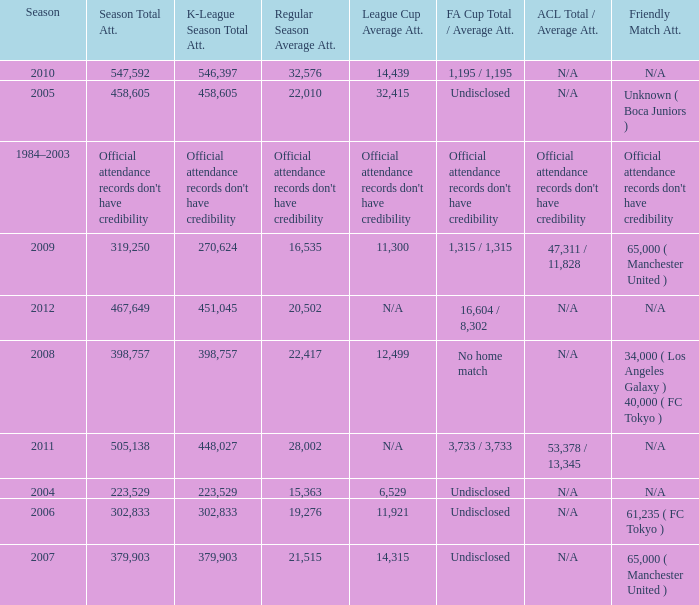Parse the full table. {'header': ['Season', 'Season Total Att.', 'K-League Season Total Att.', 'Regular Season Average Att.', 'League Cup Average Att.', 'FA Cup Total / Average Att.', 'ACL Total / Average Att.', 'Friendly Match Att.'], 'rows': [['2010', '547,592', '546,397', '32,576', '14,439', '1,195 / 1,195', 'N/A', 'N/A'], ['2005', '458,605', '458,605', '22,010', '32,415', 'Undisclosed', 'N/A', 'Unknown ( Boca Juniors )'], ['1984–2003', "Official attendance records don't have credibility", "Official attendance records don't have credibility", "Official attendance records don't have credibility", "Official attendance records don't have credibility", "Official attendance records don't have credibility", "Official attendance records don't have credibility", "Official attendance records don't have credibility"], ['2009', '319,250', '270,624', '16,535', '11,300', '1,315 / 1,315', '47,311 / 11,828', '65,000 ( Manchester United )'], ['2012', '467,649', '451,045', '20,502', 'N/A', '16,604 / 8,302', 'N/A', 'N/A'], ['2008', '398,757', '398,757', '22,417', '12,499', 'No home match', 'N/A', '34,000 ( Los Angeles Galaxy ) 40,000 ( FC Tokyo )'], ['2011', '505,138', '448,027', '28,002', 'N/A', '3,733 / 3,733', '53,378 / 13,345', 'N/A'], ['2004', '223,529', '223,529', '15,363', '6,529', 'Undisclosed', 'N/A', 'N/A'], ['2006', '302,833', '302,833', '19,276', '11,921', 'Undisclosed', 'N/A', '61,235 ( FC Tokyo )'], ['2007', '379,903', '379,903', '21,515', '14,315', 'Undisclosed', 'N/A', '65,000 ( Manchester United )']]} What was attendance of the whole season when the average attendance for League Cup was 32,415? 458605.0. 